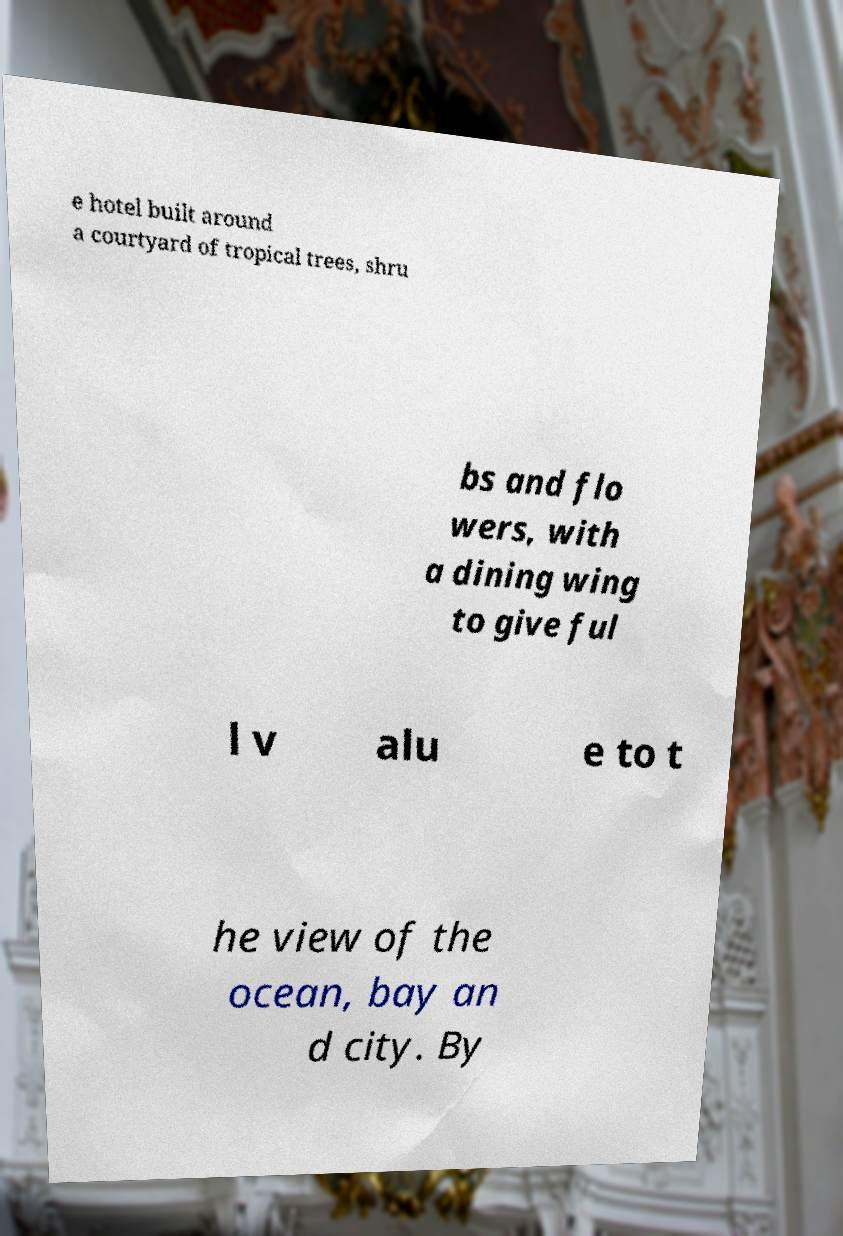Could you extract and type out the text from this image? e hotel built around a courtyard of tropical trees, shru bs and flo wers, with a dining wing to give ful l v alu e to t he view of the ocean, bay an d city. By 